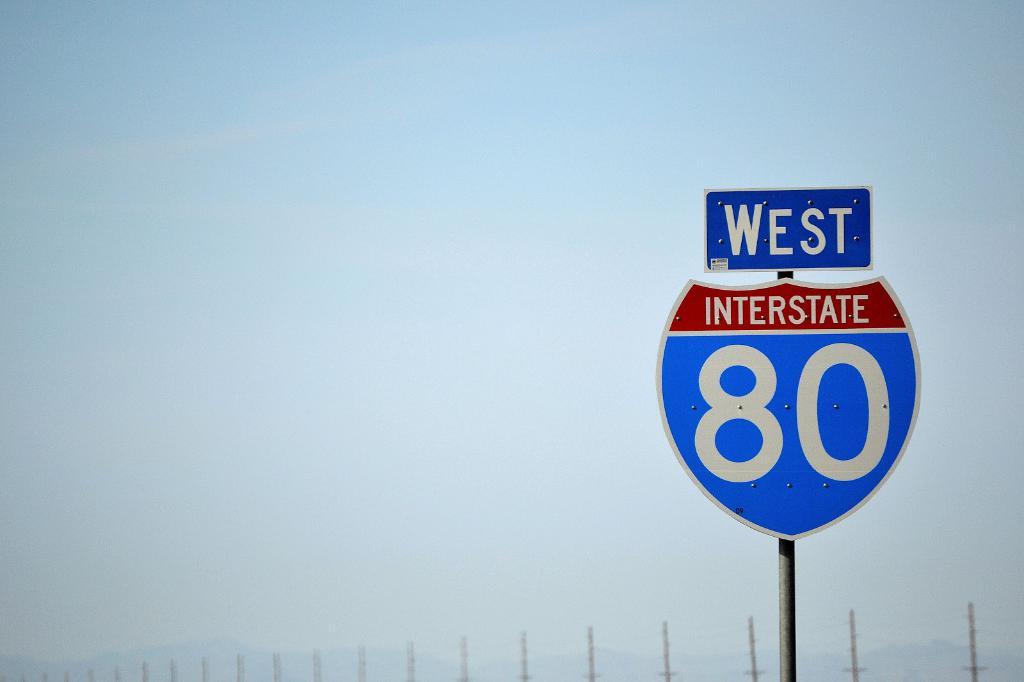Where does this highway go?
Keep it short and to the point. West. What is the number of the highway?
Ensure brevity in your answer.  80. 